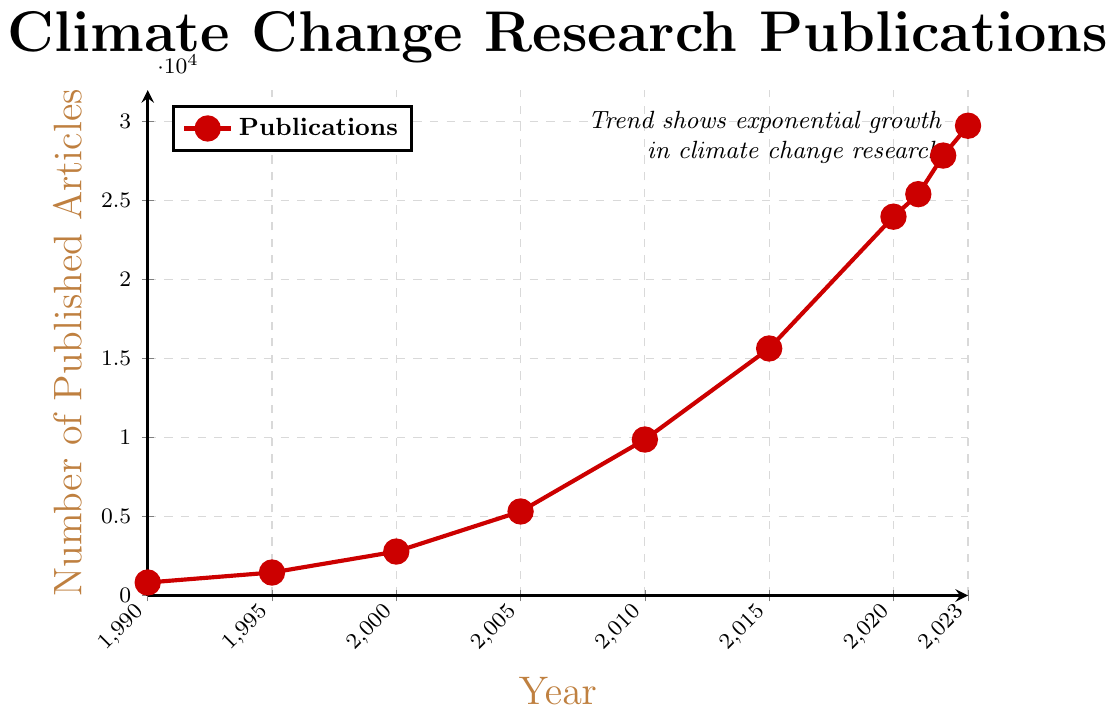Which year had the highest number of published articles? The figure shows the number of published articles for each year from 1990 to 2023. The highest point on the graph corresponds to the year 2023, with 29745 articles published.
Answer: 2023 How many articles were published in 2010? The value on the graph for the year 2010 on the x-axis can be seen to correspond to 9876 articles.
Answer: 9876 What is the difference in the number of published articles between 1995 and 2020? The number of articles published in 1995 is 1456, and in 2020 it is 23987. The difference is calculated as 23987 - 1456 = 22531.
Answer: 22531 Between which two consecutive years did the number of published articles increase by the largest amount? By inspecting the graph, the largest increase in the number of published articles seems to occur between 2010 and 2015. The number increased from 9876 to 15642, an increase of 15642 - 9876 = 5766.
Answer: 2010 and 2015 Is the trend in the number of published articles increasing or decreasing over the years? Observing the overall direction of the line in the figure from 1990 to 2023, the trend is clearly increasing, showing a rise in the number of published articles over the years.
Answer: Increasing What is the average number of published articles from 2000 to 2010? Sum the number of articles for the years 2000, 2005, and 2010: 2784 + 5321 + 9876 = 17981. There are 3 data points, so the average is 17981 / 3 ≈ 5993.67.
Answer: ~5994 How many more articles were published in 2022 compared to 1990? In 1990, 823 articles were published, and in 2022, 27856 articles were published. The difference is 27856 - 823 = 27033.
Answer: 27033 What can you infer about the trend of climate change research publications since 2000? From the visible trends in the graph, starting from the year 2000 to 2023, there is a consistent and exponential increase in the number of articles published each year.
Answer: Exponential increase 